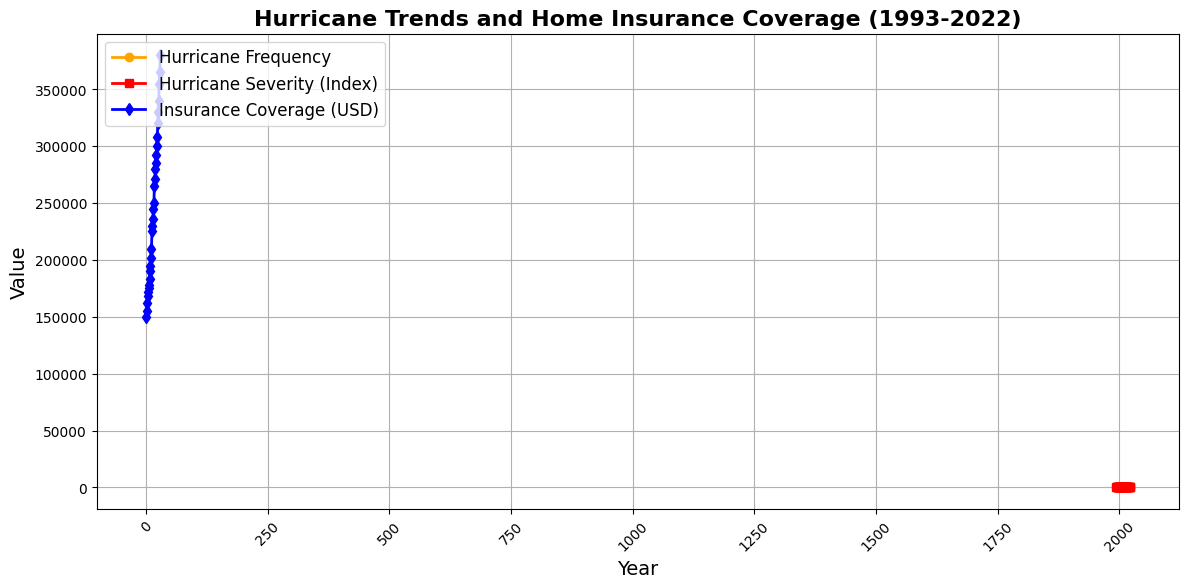What was the peak hurricane frequency over the period covered? The highest point on the orange line, which represents hurricane frequency, shows the peak value.
Answer: 12 What year had the highest hurricane severity index? Identify the position of the peak on the red line, which shows hurricane severity, and note the corresponding year.
Answer: 2022 How did the insurance coverage in USD change from 2010 to 2020? Look at the values of the blue line for the years 2010 and 2020 and calculate the difference.
Answer: Increased by 90,000 USD Which year had the lowest home insurance coverage? Determine the lowest point along the blue line, and find the corresponding year at the x-axis below that point.
Answer: 1993 How does the trend of hurricane severity between 2000 and 2010 compare to the trend of insurance coverage in the same period? Observe the red line for severity and the blue line for insurance coverage between 2000 and 2010 to assess if they are generally increasing or decreasing.
Answer: Both trends are increasing Between which two consecutive years did the insurance coverage see the largest increase? Look at the blue line and measure the greatest vertical height difference between two consecutive points.
Answer: 2009 and 2010 Did the hurricane frequency ever decrease while the insurance coverage increased? Compare the trends of the orange line and the blue line to find any periods where the frequency drops but coverage still rises.
Answer: Yes, between 2009 and 2010 What was the average hurricane severity index over the 30-year period? Find the sum of all the hurricane severity index values indicated by the red line and divide by the number of years, 30.
Answer: Approximately 2.3 Is there a correlation between hurricane severity and insurance coverage from 2005 to 2015? Examine the red line for severity and the blue line for insurance coverage during the years 2005 to 2015 and compare their shapes.
Answer: Yes, both increase What visual difference can be observed between the representation of hurricane frequency and severity compared to insurance coverage? Identify and describe any noticeable visual attributes, such as line colors, line types, and filled areas, for each of the metrics.
Answer: Hurricane frequency and severity are represented by solid lines and orange and red colors, whereas insurance coverage is represented by a blue line 